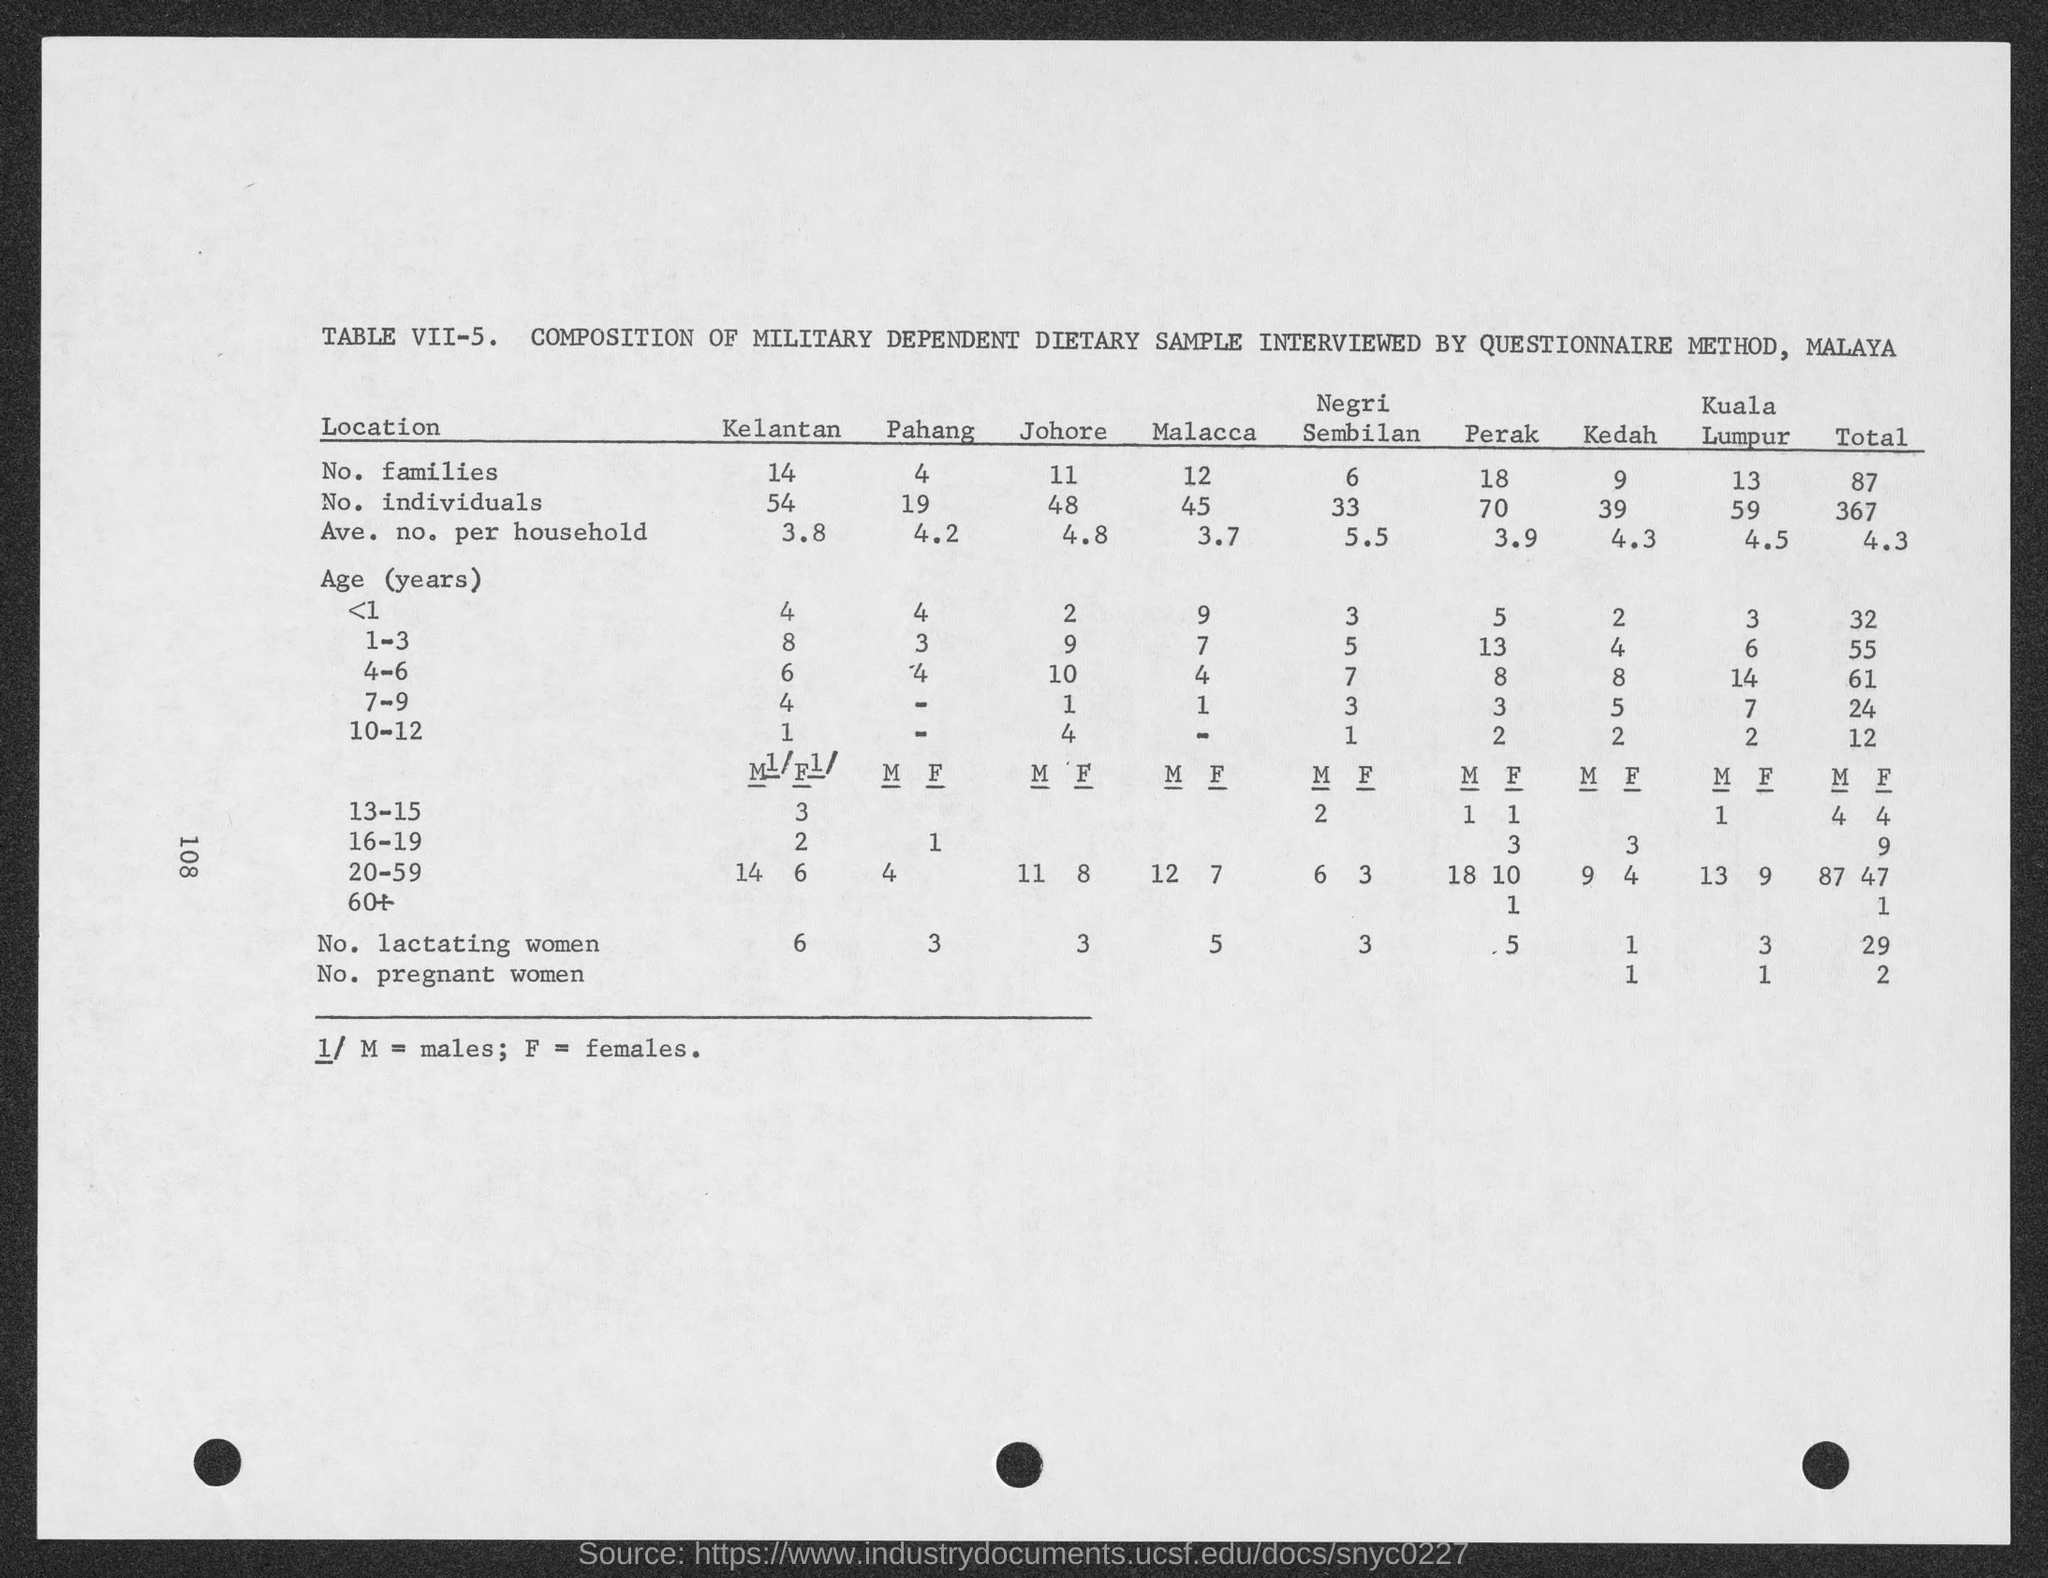what is the no. of individuals in Pahang?
 19 